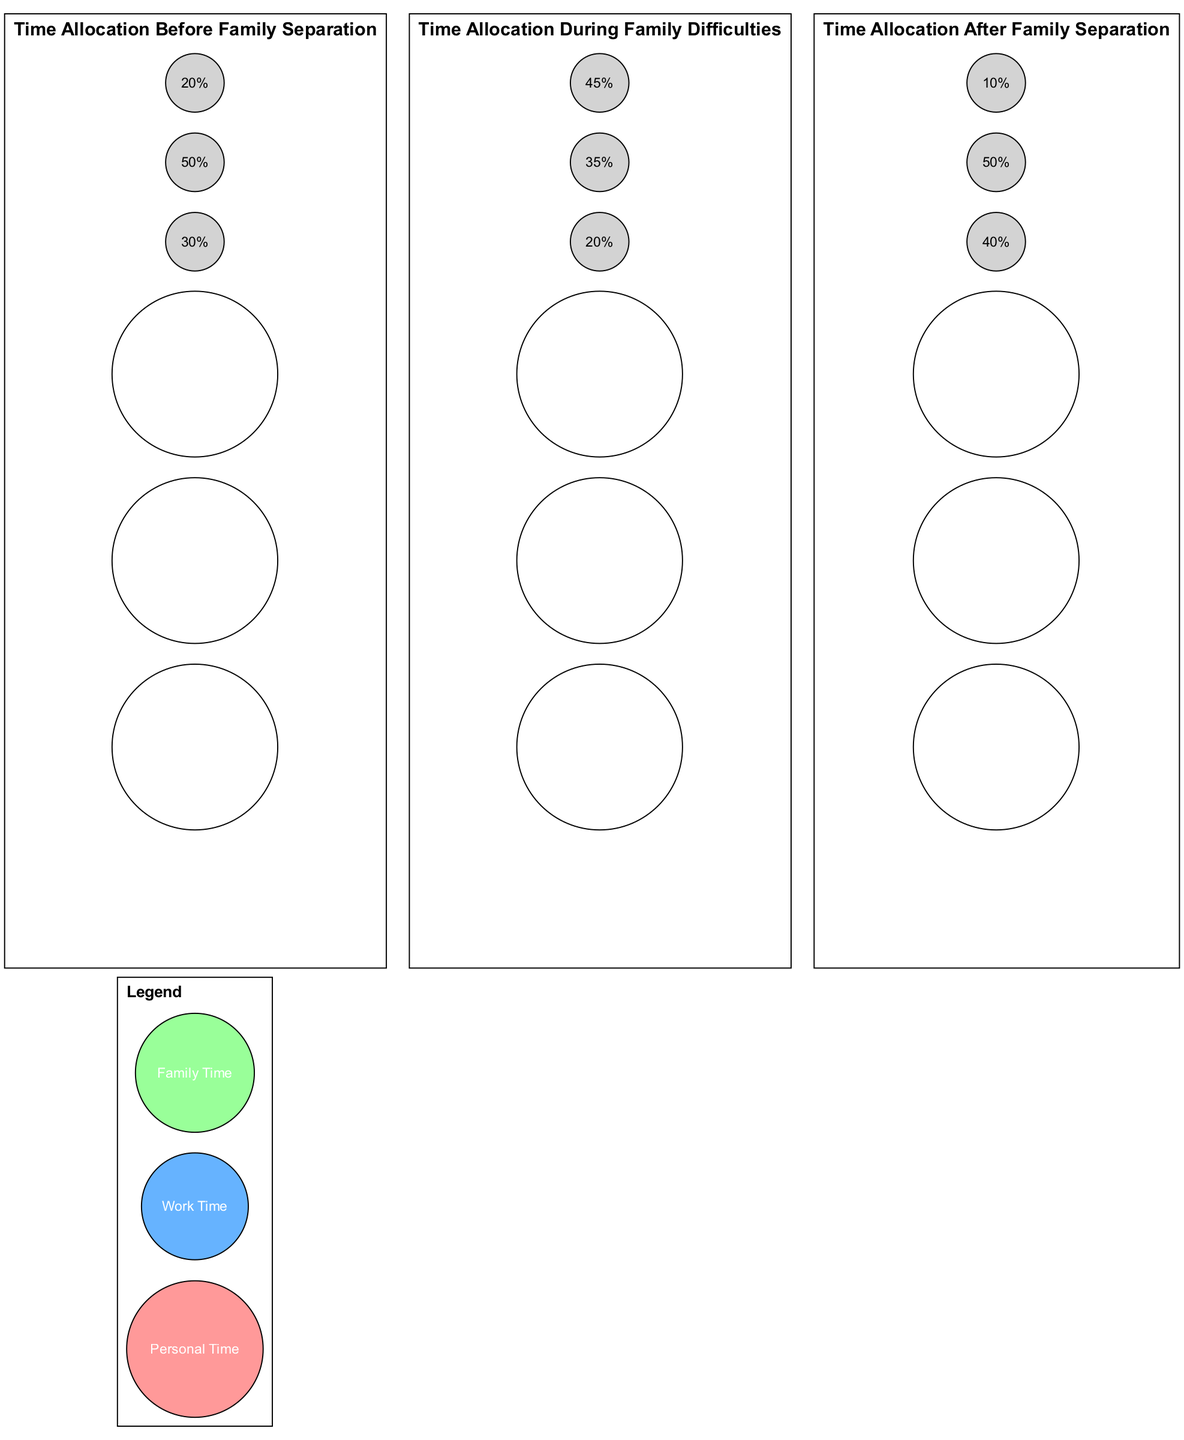What is the percentage of personal time before family separation? The diagram indicates that the percentage allocated to personal time before family separation is represented by the corresponding section of the first pie chart. This section shows 30 percent.
Answer: 30 percent What is the total percentage of work time across all stages? To find the total percentage of work time, we need to sum up the work time percentages from all three pie charts: 50 percent (before) + 35 percent (during) + 50 percent (after) equals 135 percent.
Answer: 135 percent Which time allocation had the highest percentage during family difficulties? By examining the second pie chart, we see that family time allocation during family difficulties is represented at 45 percent, which is the highest among personal and work time during that stage.
Answer: 45 percent What was the percentage change in personal time from before to after family separation? The percentage of personal time before family separation was 30 percent and after was 40 percent. To find the change, we calculate 40 percent - 30 percent, resulting in a 10 percent increase from before to after family separation.
Answer: 10 percent increase What percentage of family time is allocated after family separation? The third pie chart shows that the percentage of family time after family separation is represented by a section labeled with 10 percent.
Answer: 10 percent Which time allocation saw an increase during family difficulties compared to before family separation? When comparing the pie charts, personal time decreased from 30 percent before to 20 percent during, while family time increased from 20 percent before to 45 percent during family difficulties, indicating that family time is the allocation that increased.
Answer: Family time What was the percentage of work time during family difficulties? The second pie chart illustrates that work time during family difficulties is allocated at 35 percent.
Answer: 35 percent How does the work time allocation compare before and after family separation? The first pie chart shows work time is 50 percent before family separation, and the third pie chart shows that it is still 50 percent after family separation. Since both values are the same, there is no change in work time allocation.
Answer: No change 